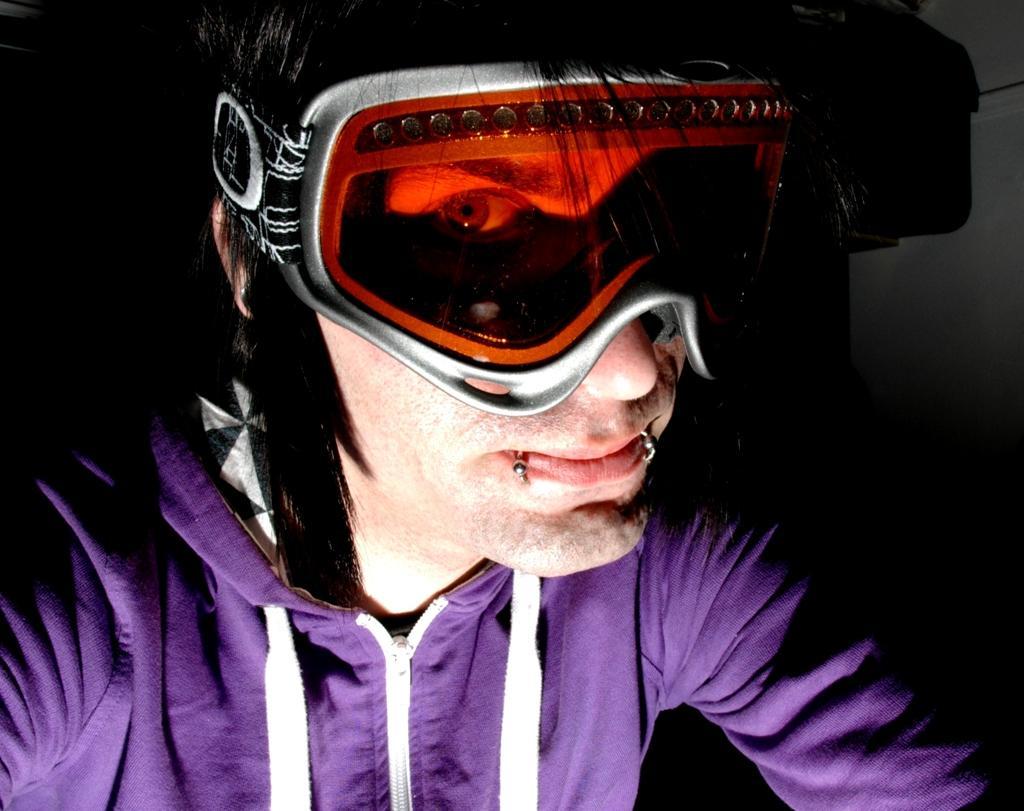Could you give a brief overview of what you see in this image? In the picture there is a man in the foreground, he is wearing goggles and a hoodie. 